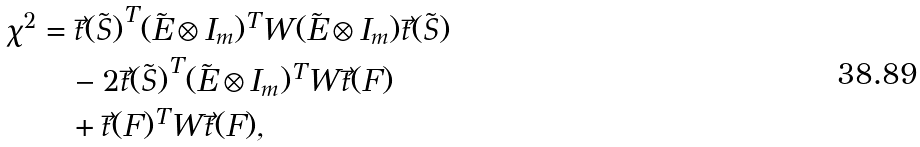<formula> <loc_0><loc_0><loc_500><loc_500>\chi ^ { 2 } & = \vec { t } { ( \tilde { S } ) } ^ { T } ( \tilde { E } \otimes I _ { m } ) ^ { T } W ( \tilde { E } \otimes I _ { m } ) \vec { t } { ( \tilde { S } ) } \\ & \quad - 2 \vec { t } { ( \tilde { S } ) } ^ { T } ( \tilde { E } \otimes I _ { m } ) ^ { T } W \vec { t } ( F ) \\ & \quad + \vec { t } ( F ) ^ { T } W \vec { t } ( F ) ,</formula> 